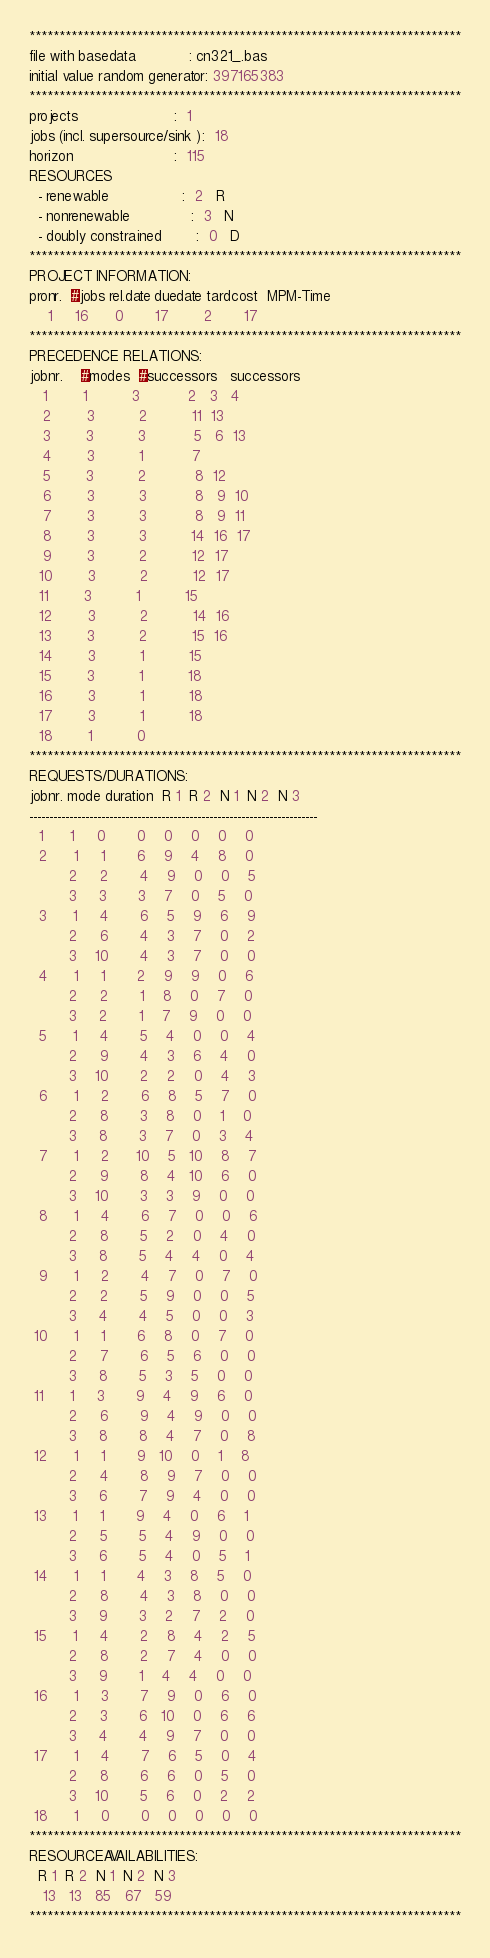<code> <loc_0><loc_0><loc_500><loc_500><_ObjectiveC_>************************************************************************
file with basedata            : cn321_.bas
initial value random generator: 397165383
************************************************************************
projects                      :  1
jobs (incl. supersource/sink ):  18
horizon                       :  115
RESOURCES
  - renewable                 :  2   R
  - nonrenewable              :  3   N
  - doubly constrained        :  0   D
************************************************************************
PROJECT INFORMATION:
pronr.  #jobs rel.date duedate tardcost  MPM-Time
    1     16      0       17        2       17
************************************************************************
PRECEDENCE RELATIONS:
jobnr.    #modes  #successors   successors
   1        1          3           2   3   4
   2        3          2          11  13
   3        3          3           5   6  13
   4        3          1           7
   5        3          2           8  12
   6        3          3           8   9  10
   7        3          3           8   9  11
   8        3          3          14  16  17
   9        3          2          12  17
  10        3          2          12  17
  11        3          1          15
  12        3          2          14  16
  13        3          2          15  16
  14        3          1          15
  15        3          1          18
  16        3          1          18
  17        3          1          18
  18        1          0        
************************************************************************
REQUESTS/DURATIONS:
jobnr. mode duration  R 1  R 2  N 1  N 2  N 3
------------------------------------------------------------------------
  1      1     0       0    0    0    0    0
  2      1     1       6    9    4    8    0
         2     2       4    9    0    0    5
         3     3       3    7    0    5    0
  3      1     4       6    5    9    6    9
         2     6       4    3    7    0    2
         3    10       4    3    7    0    0
  4      1     1       2    9    9    0    6
         2     2       1    8    0    7    0
         3     2       1    7    9    0    0
  5      1     4       5    4    0    0    4
         2     9       4    3    6    4    0
         3    10       2    2    0    4    3
  6      1     2       6    8    5    7    0
         2     8       3    8    0    1    0
         3     8       3    7    0    3    4
  7      1     2      10    5   10    8    7
         2     9       8    4   10    6    0
         3    10       3    3    9    0    0
  8      1     4       6    7    0    0    6
         2     8       5    2    0    4    0
         3     8       5    4    4    0    4
  9      1     2       4    7    0    7    0
         2     2       5    9    0    0    5
         3     4       4    5    0    0    3
 10      1     1       6    8    0    7    0
         2     7       6    5    6    0    0
         3     8       5    3    5    0    0
 11      1     3       9    4    9    6    0
         2     6       9    4    9    0    0
         3     8       8    4    7    0    8
 12      1     1       9   10    0    1    8
         2     4       8    9    7    0    0
         3     6       7    9    4    0    0
 13      1     1       9    4    0    6    1
         2     5       5    4    9    0    0
         3     6       5    4    0    5    1
 14      1     1       4    3    8    5    0
         2     8       4    3    8    0    0
         3     9       3    2    7    2    0
 15      1     4       2    8    4    2    5
         2     8       2    7    4    0    0
         3     9       1    4    4    0    0
 16      1     3       7    9    0    6    0
         2     3       6   10    0    6    6
         3     4       4    9    7    0    0
 17      1     4       7    6    5    0    4
         2     8       6    6    0    5    0
         3    10       5    6    0    2    2
 18      1     0       0    0    0    0    0
************************************************************************
RESOURCEAVAILABILITIES:
  R 1  R 2  N 1  N 2  N 3
   13   13   85   67   59
************************************************************************
</code> 